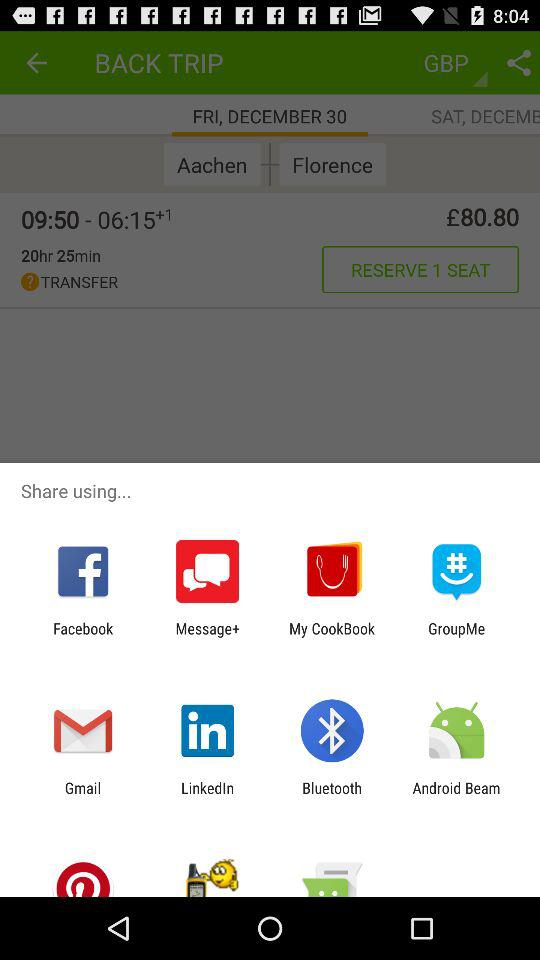How many hours is the flight?
Answer the question using a single word or phrase. 20 hours and 25 minutes 